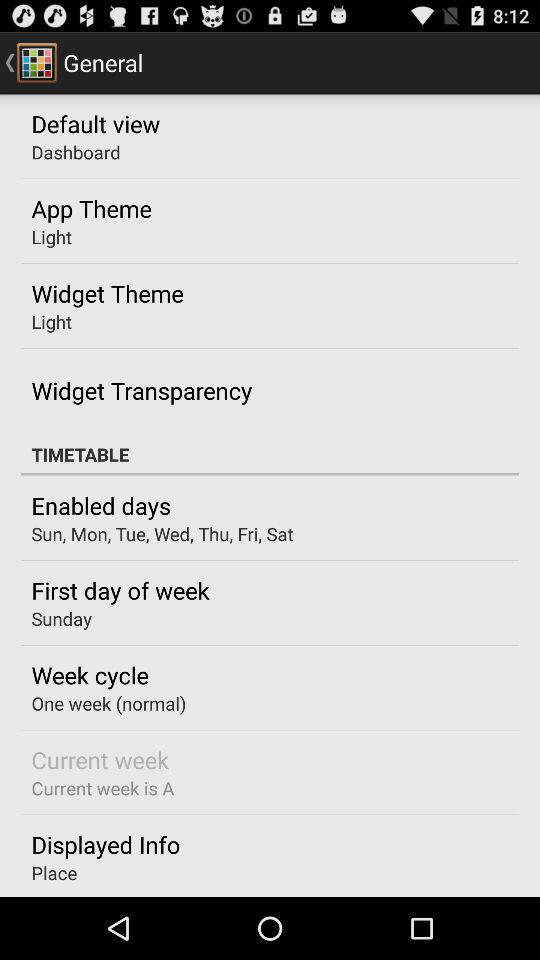What is the duration of week cycle? The duration of week cycle is one week (normal). 